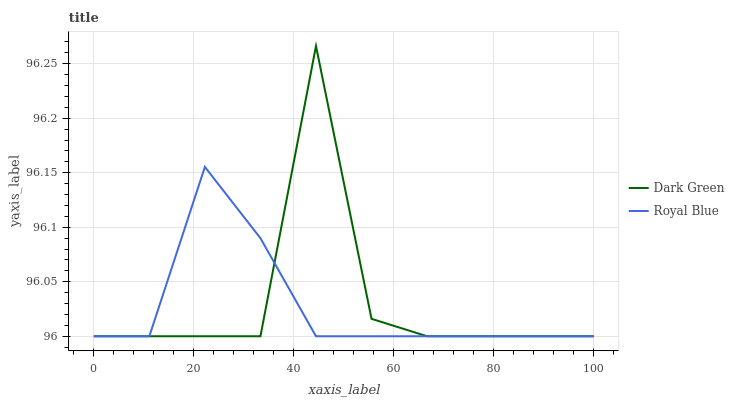Does Royal Blue have the minimum area under the curve?
Answer yes or no. Yes. Does Dark Green have the maximum area under the curve?
Answer yes or no. Yes. Does Dark Green have the minimum area under the curve?
Answer yes or no. No. Is Royal Blue the smoothest?
Answer yes or no. Yes. Is Dark Green the roughest?
Answer yes or no. Yes. Is Dark Green the smoothest?
Answer yes or no. No. Does Royal Blue have the lowest value?
Answer yes or no. Yes. Does Dark Green have the highest value?
Answer yes or no. Yes. Does Royal Blue intersect Dark Green?
Answer yes or no. Yes. Is Royal Blue less than Dark Green?
Answer yes or no. No. Is Royal Blue greater than Dark Green?
Answer yes or no. No. 